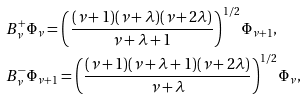<formula> <loc_0><loc_0><loc_500><loc_500>& B ^ { + } _ { \nu } \Phi _ { \nu } = \left ( \frac { ( \nu + 1 ) ( \nu + \lambda ) ( \nu + 2 \lambda ) } { \nu + \lambda + 1 } \right ) ^ { 1 / 2 } \Phi _ { \nu + 1 } , \\ & B ^ { - } _ { \nu } \Phi _ { \nu + 1 } = \left ( \frac { ( \nu + 1 ) ( \nu + \lambda + 1 ) ( \nu + 2 \lambda ) } { \nu + \lambda } \right ) ^ { 1 / 2 } \Phi _ { \nu } ,</formula> 